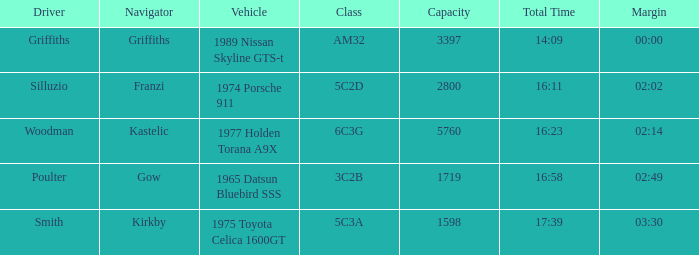Which vehicle has a class 6c3g? 1977 Holden Torana A9X. 